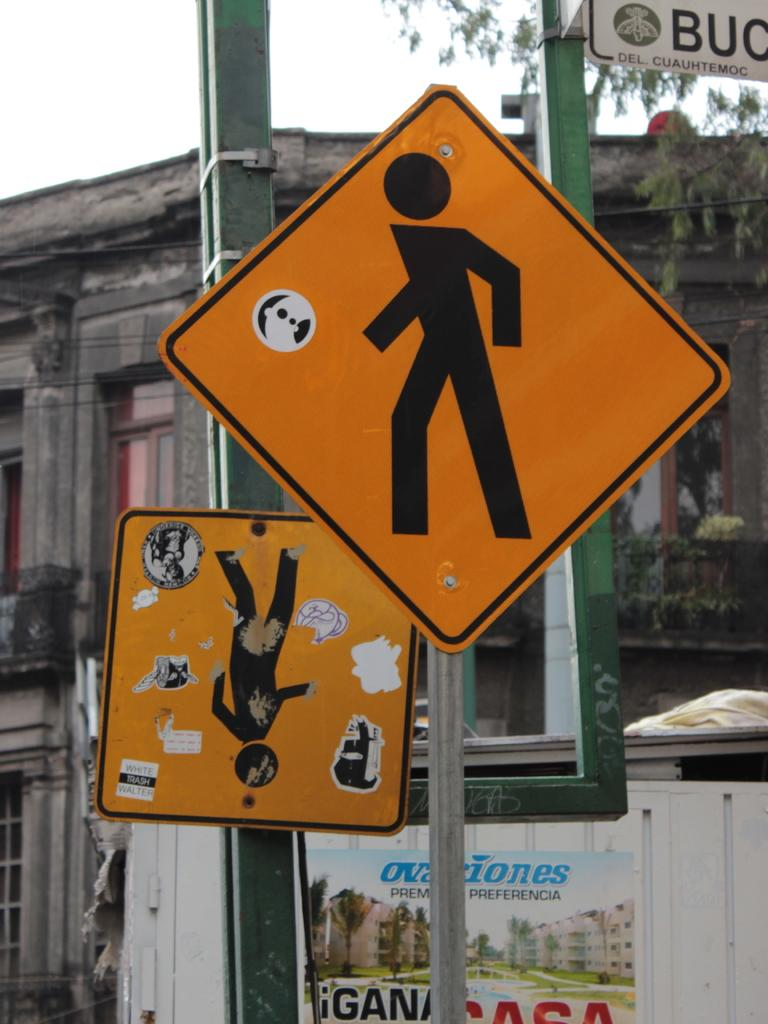<image>
Relay a brief, clear account of the picture shown. A pair of man crossing signs with the letters BUC in the upper corner. 